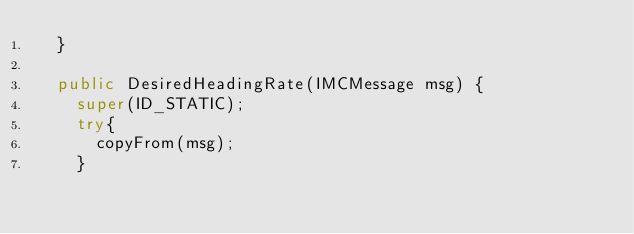Convert code to text. <code><loc_0><loc_0><loc_500><loc_500><_Java_>	}

	public DesiredHeadingRate(IMCMessage msg) {
		super(ID_STATIC);
		try{
			copyFrom(msg);
		}</code> 